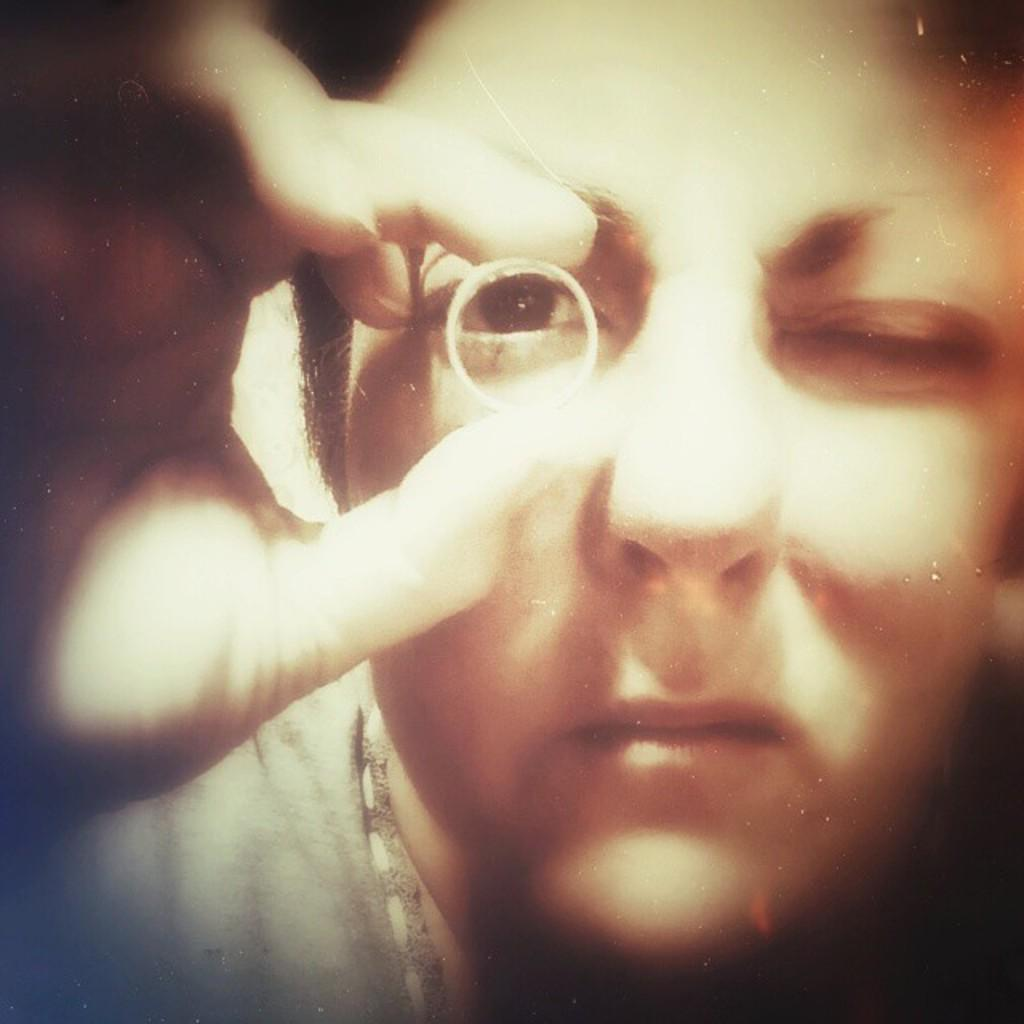What is present in the image? There is a woman in the image. What is the woman doing in the image? The woman is holding an object. What type of waste is being led by the woman in the image? There is no waste or indication of leading in the image; it only shows a woman holding an object. 